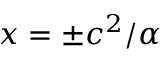Convert formula to latex. <formula><loc_0><loc_0><loc_500><loc_500>x = \pm c ^ { 2 } / \alpha</formula> 